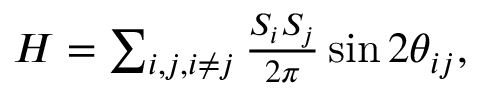<formula> <loc_0><loc_0><loc_500><loc_500>\begin{array} { r } { H = \sum _ { \substack { i , j , i \neq j } } \frac { S _ { i } S _ { j } } { 2 \pi } \sin { 2 \theta _ { i j } } , } \end{array}</formula> 